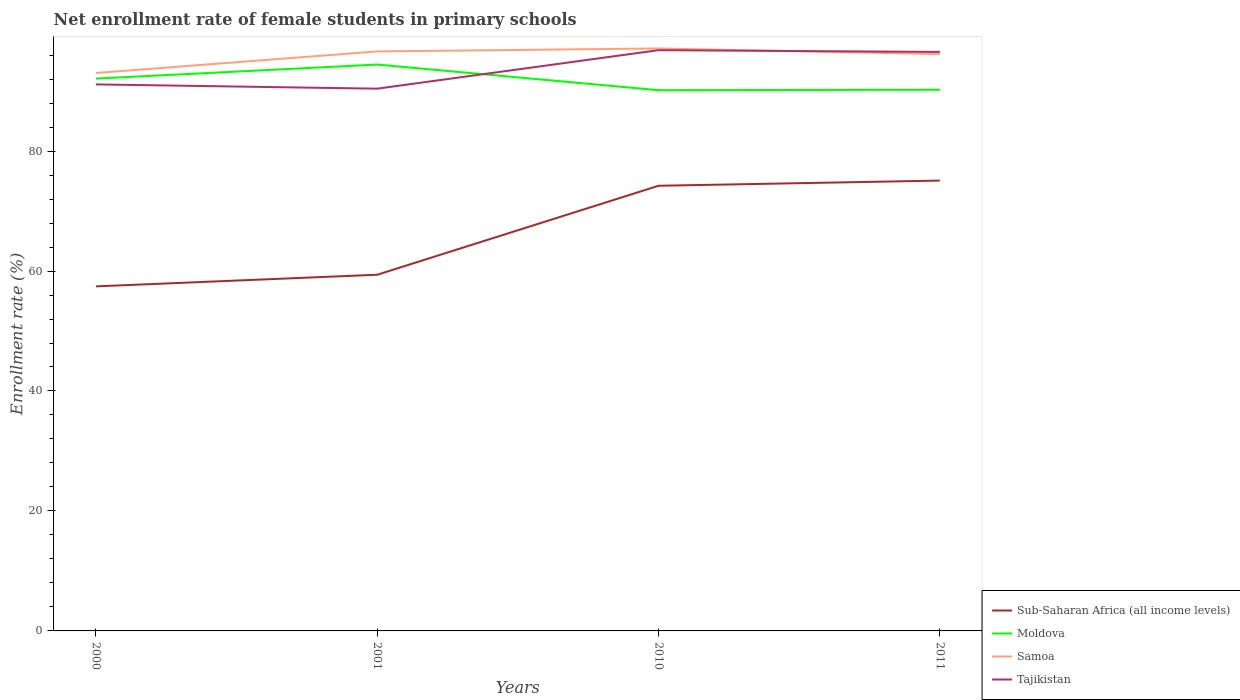How many different coloured lines are there?
Provide a short and direct response. 4. Across all years, what is the maximum net enrollment rate of female students in primary schools in Samoa?
Make the answer very short. 93.01. What is the total net enrollment rate of female students in primary schools in Tajikistan in the graph?
Give a very brief answer. -6.42. What is the difference between the highest and the second highest net enrollment rate of female students in primary schools in Samoa?
Ensure brevity in your answer.  4.09. What is the difference between the highest and the lowest net enrollment rate of female students in primary schools in Sub-Saharan Africa (all income levels)?
Provide a short and direct response. 2. Is the net enrollment rate of female students in primary schools in Sub-Saharan Africa (all income levels) strictly greater than the net enrollment rate of female students in primary schools in Moldova over the years?
Ensure brevity in your answer.  Yes. How many lines are there?
Offer a terse response. 4. What is the difference between two consecutive major ticks on the Y-axis?
Offer a terse response. 20. Does the graph contain grids?
Ensure brevity in your answer.  No. Where does the legend appear in the graph?
Make the answer very short. Bottom right. How many legend labels are there?
Provide a short and direct response. 4. How are the legend labels stacked?
Give a very brief answer. Vertical. What is the title of the graph?
Offer a very short reply. Net enrollment rate of female students in primary schools. What is the label or title of the Y-axis?
Your answer should be very brief. Enrollment rate (%). What is the Enrollment rate (%) in Sub-Saharan Africa (all income levels) in 2000?
Offer a terse response. 57.44. What is the Enrollment rate (%) of Moldova in 2000?
Ensure brevity in your answer.  92.08. What is the Enrollment rate (%) of Samoa in 2000?
Make the answer very short. 93.01. What is the Enrollment rate (%) in Tajikistan in 2000?
Provide a short and direct response. 91.11. What is the Enrollment rate (%) in Sub-Saharan Africa (all income levels) in 2001?
Provide a short and direct response. 59.38. What is the Enrollment rate (%) of Moldova in 2001?
Offer a very short reply. 94.42. What is the Enrollment rate (%) in Samoa in 2001?
Make the answer very short. 96.61. What is the Enrollment rate (%) in Tajikistan in 2001?
Offer a terse response. 90.4. What is the Enrollment rate (%) in Sub-Saharan Africa (all income levels) in 2010?
Keep it short and to the point. 74.21. What is the Enrollment rate (%) of Moldova in 2010?
Ensure brevity in your answer.  90.14. What is the Enrollment rate (%) of Samoa in 2010?
Make the answer very short. 97.1. What is the Enrollment rate (%) in Tajikistan in 2010?
Make the answer very short. 96.82. What is the Enrollment rate (%) in Sub-Saharan Africa (all income levels) in 2011?
Your response must be concise. 75.08. What is the Enrollment rate (%) in Moldova in 2011?
Provide a short and direct response. 90.22. What is the Enrollment rate (%) of Samoa in 2011?
Make the answer very short. 96.16. What is the Enrollment rate (%) of Tajikistan in 2011?
Offer a terse response. 96.52. Across all years, what is the maximum Enrollment rate (%) in Sub-Saharan Africa (all income levels)?
Provide a succinct answer. 75.08. Across all years, what is the maximum Enrollment rate (%) of Moldova?
Ensure brevity in your answer.  94.42. Across all years, what is the maximum Enrollment rate (%) in Samoa?
Your response must be concise. 97.1. Across all years, what is the maximum Enrollment rate (%) in Tajikistan?
Make the answer very short. 96.82. Across all years, what is the minimum Enrollment rate (%) in Sub-Saharan Africa (all income levels)?
Your response must be concise. 57.44. Across all years, what is the minimum Enrollment rate (%) of Moldova?
Provide a short and direct response. 90.14. Across all years, what is the minimum Enrollment rate (%) of Samoa?
Offer a terse response. 93.01. Across all years, what is the minimum Enrollment rate (%) in Tajikistan?
Give a very brief answer. 90.4. What is the total Enrollment rate (%) of Sub-Saharan Africa (all income levels) in the graph?
Make the answer very short. 266.11. What is the total Enrollment rate (%) in Moldova in the graph?
Keep it short and to the point. 366.87. What is the total Enrollment rate (%) of Samoa in the graph?
Your answer should be very brief. 382.89. What is the total Enrollment rate (%) in Tajikistan in the graph?
Your response must be concise. 374.86. What is the difference between the Enrollment rate (%) of Sub-Saharan Africa (all income levels) in 2000 and that in 2001?
Your response must be concise. -1.94. What is the difference between the Enrollment rate (%) of Moldova in 2000 and that in 2001?
Give a very brief answer. -2.34. What is the difference between the Enrollment rate (%) of Samoa in 2000 and that in 2001?
Provide a short and direct response. -3.6. What is the difference between the Enrollment rate (%) in Tajikistan in 2000 and that in 2001?
Make the answer very short. 0.71. What is the difference between the Enrollment rate (%) in Sub-Saharan Africa (all income levels) in 2000 and that in 2010?
Give a very brief answer. -16.77. What is the difference between the Enrollment rate (%) in Moldova in 2000 and that in 2010?
Provide a short and direct response. 1.94. What is the difference between the Enrollment rate (%) of Samoa in 2000 and that in 2010?
Your response must be concise. -4.09. What is the difference between the Enrollment rate (%) in Tajikistan in 2000 and that in 2010?
Ensure brevity in your answer.  -5.71. What is the difference between the Enrollment rate (%) in Sub-Saharan Africa (all income levels) in 2000 and that in 2011?
Your response must be concise. -17.64. What is the difference between the Enrollment rate (%) in Moldova in 2000 and that in 2011?
Provide a succinct answer. 1.86. What is the difference between the Enrollment rate (%) in Samoa in 2000 and that in 2011?
Provide a short and direct response. -3.15. What is the difference between the Enrollment rate (%) in Tajikistan in 2000 and that in 2011?
Make the answer very short. -5.41. What is the difference between the Enrollment rate (%) of Sub-Saharan Africa (all income levels) in 2001 and that in 2010?
Offer a very short reply. -14.83. What is the difference between the Enrollment rate (%) in Moldova in 2001 and that in 2010?
Ensure brevity in your answer.  4.27. What is the difference between the Enrollment rate (%) in Samoa in 2001 and that in 2010?
Your response must be concise. -0.49. What is the difference between the Enrollment rate (%) in Tajikistan in 2001 and that in 2010?
Your answer should be compact. -6.42. What is the difference between the Enrollment rate (%) of Sub-Saharan Africa (all income levels) in 2001 and that in 2011?
Your response must be concise. -15.7. What is the difference between the Enrollment rate (%) of Moldova in 2001 and that in 2011?
Make the answer very short. 4.2. What is the difference between the Enrollment rate (%) in Samoa in 2001 and that in 2011?
Give a very brief answer. 0.45. What is the difference between the Enrollment rate (%) of Tajikistan in 2001 and that in 2011?
Your response must be concise. -6.12. What is the difference between the Enrollment rate (%) of Sub-Saharan Africa (all income levels) in 2010 and that in 2011?
Provide a short and direct response. -0.86. What is the difference between the Enrollment rate (%) in Moldova in 2010 and that in 2011?
Ensure brevity in your answer.  -0.07. What is the difference between the Enrollment rate (%) in Samoa in 2010 and that in 2011?
Give a very brief answer. 0.94. What is the difference between the Enrollment rate (%) of Tajikistan in 2010 and that in 2011?
Your answer should be very brief. 0.3. What is the difference between the Enrollment rate (%) in Sub-Saharan Africa (all income levels) in 2000 and the Enrollment rate (%) in Moldova in 2001?
Ensure brevity in your answer.  -36.98. What is the difference between the Enrollment rate (%) of Sub-Saharan Africa (all income levels) in 2000 and the Enrollment rate (%) of Samoa in 2001?
Your answer should be very brief. -39.17. What is the difference between the Enrollment rate (%) of Sub-Saharan Africa (all income levels) in 2000 and the Enrollment rate (%) of Tajikistan in 2001?
Give a very brief answer. -32.96. What is the difference between the Enrollment rate (%) in Moldova in 2000 and the Enrollment rate (%) in Samoa in 2001?
Provide a short and direct response. -4.53. What is the difference between the Enrollment rate (%) of Moldova in 2000 and the Enrollment rate (%) of Tajikistan in 2001?
Provide a succinct answer. 1.68. What is the difference between the Enrollment rate (%) in Samoa in 2000 and the Enrollment rate (%) in Tajikistan in 2001?
Keep it short and to the point. 2.61. What is the difference between the Enrollment rate (%) of Sub-Saharan Africa (all income levels) in 2000 and the Enrollment rate (%) of Moldova in 2010?
Provide a succinct answer. -32.71. What is the difference between the Enrollment rate (%) of Sub-Saharan Africa (all income levels) in 2000 and the Enrollment rate (%) of Samoa in 2010?
Your answer should be very brief. -39.66. What is the difference between the Enrollment rate (%) of Sub-Saharan Africa (all income levels) in 2000 and the Enrollment rate (%) of Tajikistan in 2010?
Offer a very short reply. -39.38. What is the difference between the Enrollment rate (%) of Moldova in 2000 and the Enrollment rate (%) of Samoa in 2010?
Offer a very short reply. -5.02. What is the difference between the Enrollment rate (%) of Moldova in 2000 and the Enrollment rate (%) of Tajikistan in 2010?
Offer a terse response. -4.74. What is the difference between the Enrollment rate (%) in Samoa in 2000 and the Enrollment rate (%) in Tajikistan in 2010?
Make the answer very short. -3.81. What is the difference between the Enrollment rate (%) in Sub-Saharan Africa (all income levels) in 2000 and the Enrollment rate (%) in Moldova in 2011?
Your answer should be compact. -32.78. What is the difference between the Enrollment rate (%) of Sub-Saharan Africa (all income levels) in 2000 and the Enrollment rate (%) of Samoa in 2011?
Your answer should be compact. -38.72. What is the difference between the Enrollment rate (%) in Sub-Saharan Africa (all income levels) in 2000 and the Enrollment rate (%) in Tajikistan in 2011?
Your answer should be compact. -39.08. What is the difference between the Enrollment rate (%) in Moldova in 2000 and the Enrollment rate (%) in Samoa in 2011?
Your response must be concise. -4.08. What is the difference between the Enrollment rate (%) in Moldova in 2000 and the Enrollment rate (%) in Tajikistan in 2011?
Offer a very short reply. -4.44. What is the difference between the Enrollment rate (%) of Samoa in 2000 and the Enrollment rate (%) of Tajikistan in 2011?
Make the answer very short. -3.51. What is the difference between the Enrollment rate (%) of Sub-Saharan Africa (all income levels) in 2001 and the Enrollment rate (%) of Moldova in 2010?
Make the answer very short. -30.76. What is the difference between the Enrollment rate (%) in Sub-Saharan Africa (all income levels) in 2001 and the Enrollment rate (%) in Samoa in 2010?
Offer a terse response. -37.72. What is the difference between the Enrollment rate (%) in Sub-Saharan Africa (all income levels) in 2001 and the Enrollment rate (%) in Tajikistan in 2010?
Ensure brevity in your answer.  -37.44. What is the difference between the Enrollment rate (%) in Moldova in 2001 and the Enrollment rate (%) in Samoa in 2010?
Your response must be concise. -2.68. What is the difference between the Enrollment rate (%) in Moldova in 2001 and the Enrollment rate (%) in Tajikistan in 2010?
Provide a short and direct response. -2.4. What is the difference between the Enrollment rate (%) in Samoa in 2001 and the Enrollment rate (%) in Tajikistan in 2010?
Your answer should be compact. -0.21. What is the difference between the Enrollment rate (%) of Sub-Saharan Africa (all income levels) in 2001 and the Enrollment rate (%) of Moldova in 2011?
Your response must be concise. -30.84. What is the difference between the Enrollment rate (%) in Sub-Saharan Africa (all income levels) in 2001 and the Enrollment rate (%) in Samoa in 2011?
Provide a short and direct response. -36.78. What is the difference between the Enrollment rate (%) of Sub-Saharan Africa (all income levels) in 2001 and the Enrollment rate (%) of Tajikistan in 2011?
Offer a very short reply. -37.14. What is the difference between the Enrollment rate (%) of Moldova in 2001 and the Enrollment rate (%) of Samoa in 2011?
Your answer should be very brief. -1.74. What is the difference between the Enrollment rate (%) of Moldova in 2001 and the Enrollment rate (%) of Tajikistan in 2011?
Your answer should be compact. -2.1. What is the difference between the Enrollment rate (%) in Samoa in 2001 and the Enrollment rate (%) in Tajikistan in 2011?
Provide a short and direct response. 0.09. What is the difference between the Enrollment rate (%) of Sub-Saharan Africa (all income levels) in 2010 and the Enrollment rate (%) of Moldova in 2011?
Give a very brief answer. -16.01. What is the difference between the Enrollment rate (%) in Sub-Saharan Africa (all income levels) in 2010 and the Enrollment rate (%) in Samoa in 2011?
Your answer should be very brief. -21.95. What is the difference between the Enrollment rate (%) in Sub-Saharan Africa (all income levels) in 2010 and the Enrollment rate (%) in Tajikistan in 2011?
Your answer should be compact. -22.31. What is the difference between the Enrollment rate (%) of Moldova in 2010 and the Enrollment rate (%) of Samoa in 2011?
Keep it short and to the point. -6.01. What is the difference between the Enrollment rate (%) in Moldova in 2010 and the Enrollment rate (%) in Tajikistan in 2011?
Make the answer very short. -6.38. What is the difference between the Enrollment rate (%) in Samoa in 2010 and the Enrollment rate (%) in Tajikistan in 2011?
Provide a short and direct response. 0.58. What is the average Enrollment rate (%) in Sub-Saharan Africa (all income levels) per year?
Keep it short and to the point. 66.53. What is the average Enrollment rate (%) of Moldova per year?
Keep it short and to the point. 91.72. What is the average Enrollment rate (%) in Samoa per year?
Your answer should be very brief. 95.72. What is the average Enrollment rate (%) of Tajikistan per year?
Give a very brief answer. 93.71. In the year 2000, what is the difference between the Enrollment rate (%) of Sub-Saharan Africa (all income levels) and Enrollment rate (%) of Moldova?
Offer a terse response. -34.64. In the year 2000, what is the difference between the Enrollment rate (%) in Sub-Saharan Africa (all income levels) and Enrollment rate (%) in Samoa?
Give a very brief answer. -35.57. In the year 2000, what is the difference between the Enrollment rate (%) in Sub-Saharan Africa (all income levels) and Enrollment rate (%) in Tajikistan?
Make the answer very short. -33.67. In the year 2000, what is the difference between the Enrollment rate (%) in Moldova and Enrollment rate (%) in Samoa?
Give a very brief answer. -0.93. In the year 2000, what is the difference between the Enrollment rate (%) of Moldova and Enrollment rate (%) of Tajikistan?
Your answer should be compact. 0.97. In the year 2000, what is the difference between the Enrollment rate (%) of Samoa and Enrollment rate (%) of Tajikistan?
Your answer should be compact. 1.9. In the year 2001, what is the difference between the Enrollment rate (%) of Sub-Saharan Africa (all income levels) and Enrollment rate (%) of Moldova?
Give a very brief answer. -35.04. In the year 2001, what is the difference between the Enrollment rate (%) in Sub-Saharan Africa (all income levels) and Enrollment rate (%) in Samoa?
Provide a short and direct response. -37.23. In the year 2001, what is the difference between the Enrollment rate (%) in Sub-Saharan Africa (all income levels) and Enrollment rate (%) in Tajikistan?
Give a very brief answer. -31.02. In the year 2001, what is the difference between the Enrollment rate (%) in Moldova and Enrollment rate (%) in Samoa?
Keep it short and to the point. -2.19. In the year 2001, what is the difference between the Enrollment rate (%) in Moldova and Enrollment rate (%) in Tajikistan?
Give a very brief answer. 4.02. In the year 2001, what is the difference between the Enrollment rate (%) in Samoa and Enrollment rate (%) in Tajikistan?
Give a very brief answer. 6.21. In the year 2010, what is the difference between the Enrollment rate (%) in Sub-Saharan Africa (all income levels) and Enrollment rate (%) in Moldova?
Offer a very short reply. -15.93. In the year 2010, what is the difference between the Enrollment rate (%) in Sub-Saharan Africa (all income levels) and Enrollment rate (%) in Samoa?
Your response must be concise. -22.89. In the year 2010, what is the difference between the Enrollment rate (%) of Sub-Saharan Africa (all income levels) and Enrollment rate (%) of Tajikistan?
Give a very brief answer. -22.61. In the year 2010, what is the difference between the Enrollment rate (%) in Moldova and Enrollment rate (%) in Samoa?
Give a very brief answer. -6.96. In the year 2010, what is the difference between the Enrollment rate (%) of Moldova and Enrollment rate (%) of Tajikistan?
Provide a short and direct response. -6.68. In the year 2010, what is the difference between the Enrollment rate (%) in Samoa and Enrollment rate (%) in Tajikistan?
Offer a terse response. 0.28. In the year 2011, what is the difference between the Enrollment rate (%) of Sub-Saharan Africa (all income levels) and Enrollment rate (%) of Moldova?
Keep it short and to the point. -15.14. In the year 2011, what is the difference between the Enrollment rate (%) in Sub-Saharan Africa (all income levels) and Enrollment rate (%) in Samoa?
Your answer should be compact. -21.08. In the year 2011, what is the difference between the Enrollment rate (%) of Sub-Saharan Africa (all income levels) and Enrollment rate (%) of Tajikistan?
Your answer should be compact. -21.45. In the year 2011, what is the difference between the Enrollment rate (%) in Moldova and Enrollment rate (%) in Samoa?
Ensure brevity in your answer.  -5.94. In the year 2011, what is the difference between the Enrollment rate (%) in Moldova and Enrollment rate (%) in Tajikistan?
Give a very brief answer. -6.3. In the year 2011, what is the difference between the Enrollment rate (%) of Samoa and Enrollment rate (%) of Tajikistan?
Make the answer very short. -0.36. What is the ratio of the Enrollment rate (%) of Sub-Saharan Africa (all income levels) in 2000 to that in 2001?
Offer a terse response. 0.97. What is the ratio of the Enrollment rate (%) in Moldova in 2000 to that in 2001?
Keep it short and to the point. 0.98. What is the ratio of the Enrollment rate (%) in Samoa in 2000 to that in 2001?
Offer a very short reply. 0.96. What is the ratio of the Enrollment rate (%) in Tajikistan in 2000 to that in 2001?
Offer a very short reply. 1.01. What is the ratio of the Enrollment rate (%) in Sub-Saharan Africa (all income levels) in 2000 to that in 2010?
Provide a succinct answer. 0.77. What is the ratio of the Enrollment rate (%) in Moldova in 2000 to that in 2010?
Offer a terse response. 1.02. What is the ratio of the Enrollment rate (%) of Samoa in 2000 to that in 2010?
Provide a succinct answer. 0.96. What is the ratio of the Enrollment rate (%) of Tajikistan in 2000 to that in 2010?
Your answer should be very brief. 0.94. What is the ratio of the Enrollment rate (%) in Sub-Saharan Africa (all income levels) in 2000 to that in 2011?
Your response must be concise. 0.77. What is the ratio of the Enrollment rate (%) of Moldova in 2000 to that in 2011?
Provide a short and direct response. 1.02. What is the ratio of the Enrollment rate (%) of Samoa in 2000 to that in 2011?
Your answer should be very brief. 0.97. What is the ratio of the Enrollment rate (%) of Tajikistan in 2000 to that in 2011?
Your answer should be compact. 0.94. What is the ratio of the Enrollment rate (%) of Sub-Saharan Africa (all income levels) in 2001 to that in 2010?
Ensure brevity in your answer.  0.8. What is the ratio of the Enrollment rate (%) of Moldova in 2001 to that in 2010?
Offer a terse response. 1.05. What is the ratio of the Enrollment rate (%) of Samoa in 2001 to that in 2010?
Your response must be concise. 0.99. What is the ratio of the Enrollment rate (%) in Tajikistan in 2001 to that in 2010?
Ensure brevity in your answer.  0.93. What is the ratio of the Enrollment rate (%) of Sub-Saharan Africa (all income levels) in 2001 to that in 2011?
Give a very brief answer. 0.79. What is the ratio of the Enrollment rate (%) of Moldova in 2001 to that in 2011?
Give a very brief answer. 1.05. What is the ratio of the Enrollment rate (%) of Samoa in 2001 to that in 2011?
Keep it short and to the point. 1. What is the ratio of the Enrollment rate (%) in Tajikistan in 2001 to that in 2011?
Provide a short and direct response. 0.94. What is the ratio of the Enrollment rate (%) of Sub-Saharan Africa (all income levels) in 2010 to that in 2011?
Make the answer very short. 0.99. What is the ratio of the Enrollment rate (%) in Samoa in 2010 to that in 2011?
Offer a terse response. 1.01. What is the difference between the highest and the second highest Enrollment rate (%) in Sub-Saharan Africa (all income levels)?
Offer a terse response. 0.86. What is the difference between the highest and the second highest Enrollment rate (%) in Moldova?
Ensure brevity in your answer.  2.34. What is the difference between the highest and the second highest Enrollment rate (%) of Samoa?
Provide a succinct answer. 0.49. What is the difference between the highest and the second highest Enrollment rate (%) of Tajikistan?
Keep it short and to the point. 0.3. What is the difference between the highest and the lowest Enrollment rate (%) in Sub-Saharan Africa (all income levels)?
Offer a terse response. 17.64. What is the difference between the highest and the lowest Enrollment rate (%) in Moldova?
Your answer should be compact. 4.27. What is the difference between the highest and the lowest Enrollment rate (%) in Samoa?
Provide a succinct answer. 4.09. What is the difference between the highest and the lowest Enrollment rate (%) of Tajikistan?
Provide a short and direct response. 6.42. 